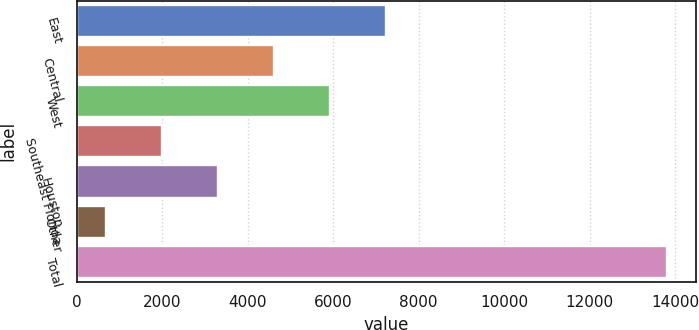Convert chart. <chart><loc_0><loc_0><loc_500><loc_500><bar_chart><fcel>East<fcel>Central<fcel>West<fcel>Southeast Florida<fcel>Houston<fcel>Other<fcel>Total<nl><fcel>7239<fcel>4613.8<fcel>5926.4<fcel>1988.6<fcel>3301.2<fcel>676<fcel>13802<nl></chart> 